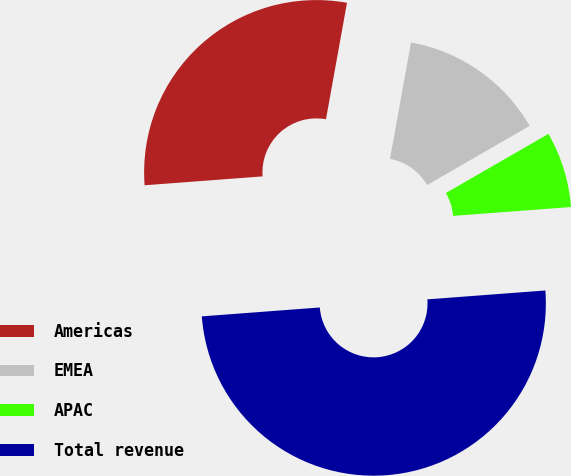Convert chart to OTSL. <chart><loc_0><loc_0><loc_500><loc_500><pie_chart><fcel>Americas<fcel>EMEA<fcel>APAC<fcel>Total revenue<nl><fcel>29.04%<fcel>13.83%<fcel>7.13%<fcel>50.0%<nl></chart> 